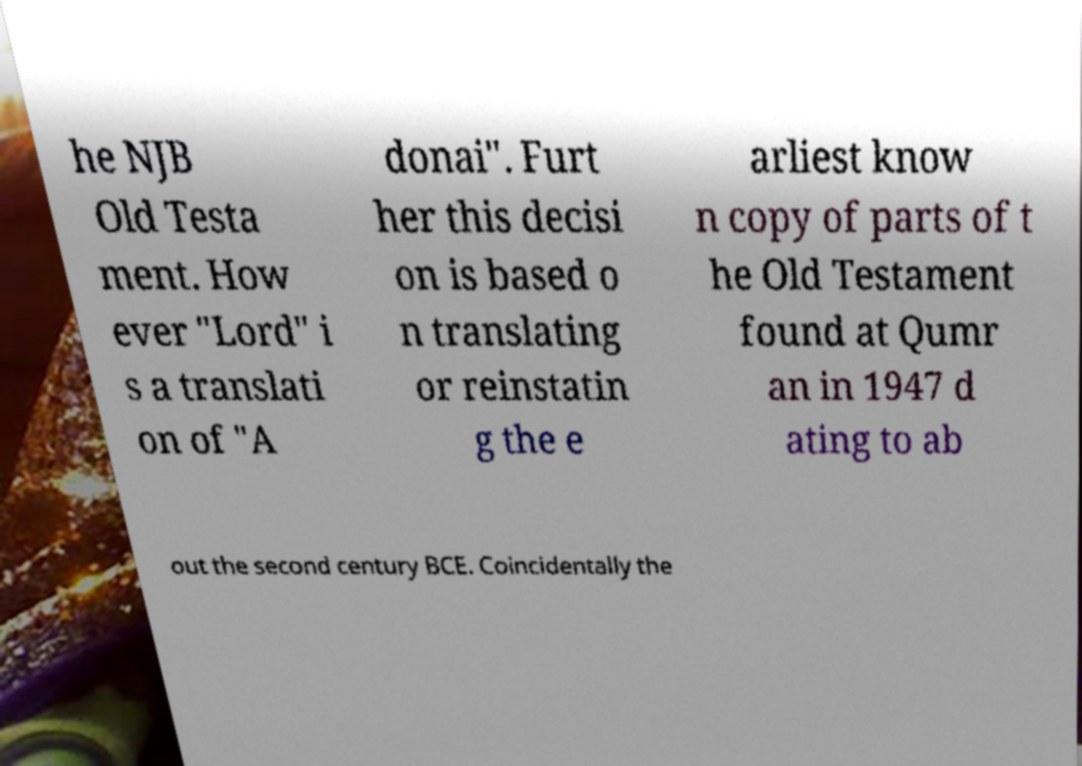What messages or text are displayed in this image? I need them in a readable, typed format. he NJB Old Testa ment. How ever "Lord" i s a translati on of "A donai". Furt her this decisi on is based o n translating or reinstatin g the e arliest know n copy of parts of t he Old Testament found at Qumr an in 1947 d ating to ab out the second century BCE. Coincidentally the 